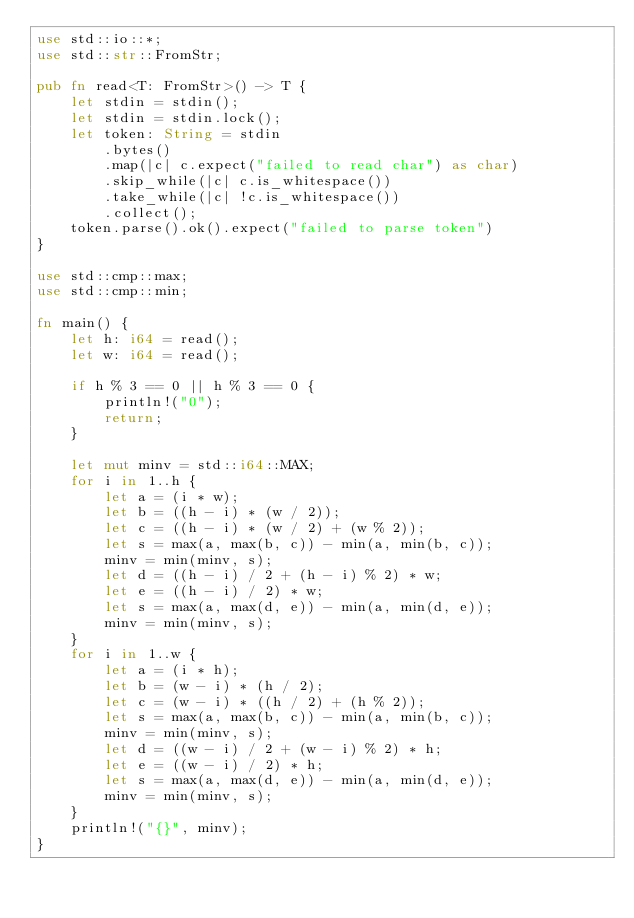Convert code to text. <code><loc_0><loc_0><loc_500><loc_500><_Rust_>use std::io::*;
use std::str::FromStr;

pub fn read<T: FromStr>() -> T {
    let stdin = stdin();
    let stdin = stdin.lock();
    let token: String = stdin
        .bytes()
        .map(|c| c.expect("failed to read char") as char)
        .skip_while(|c| c.is_whitespace())
        .take_while(|c| !c.is_whitespace())
        .collect();
    token.parse().ok().expect("failed to parse token")
}

use std::cmp::max;
use std::cmp::min;

fn main() {
    let h: i64 = read();
    let w: i64 = read();

    if h % 3 == 0 || h % 3 == 0 {
        println!("0");
        return;
    }

    let mut minv = std::i64::MAX;
    for i in 1..h {
        let a = (i * w);
        let b = ((h - i) * (w / 2));
        let c = ((h - i) * (w / 2) + (w % 2));
        let s = max(a, max(b, c)) - min(a, min(b, c));
        minv = min(minv, s);
        let d = ((h - i) / 2 + (h - i) % 2) * w;
        let e = ((h - i) / 2) * w;
        let s = max(a, max(d, e)) - min(a, min(d, e));
        minv = min(minv, s);
    }
    for i in 1..w {
        let a = (i * h);
        let b = (w - i) * (h / 2);
        let c = (w - i) * ((h / 2) + (h % 2));
        let s = max(a, max(b, c)) - min(a, min(b, c));
        minv = min(minv, s);
        let d = ((w - i) / 2 + (w - i) % 2) * h;
        let e = ((w - i) / 2) * h;
        let s = max(a, max(d, e)) - min(a, min(d, e));
        minv = min(minv, s);
    }
    println!("{}", minv);
}
</code> 